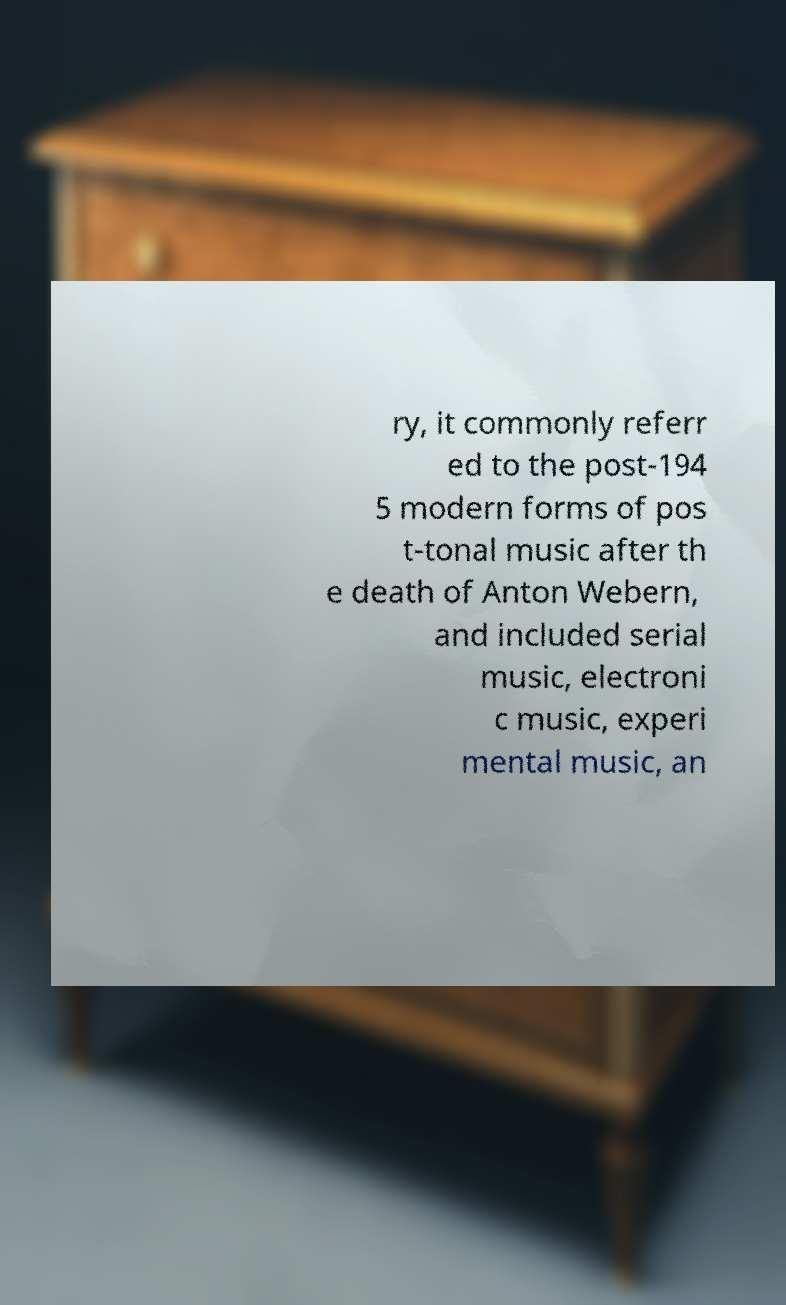Could you assist in decoding the text presented in this image and type it out clearly? ry, it commonly referr ed to the post-194 5 modern forms of pos t-tonal music after th e death of Anton Webern, and included serial music, electroni c music, experi mental music, an 